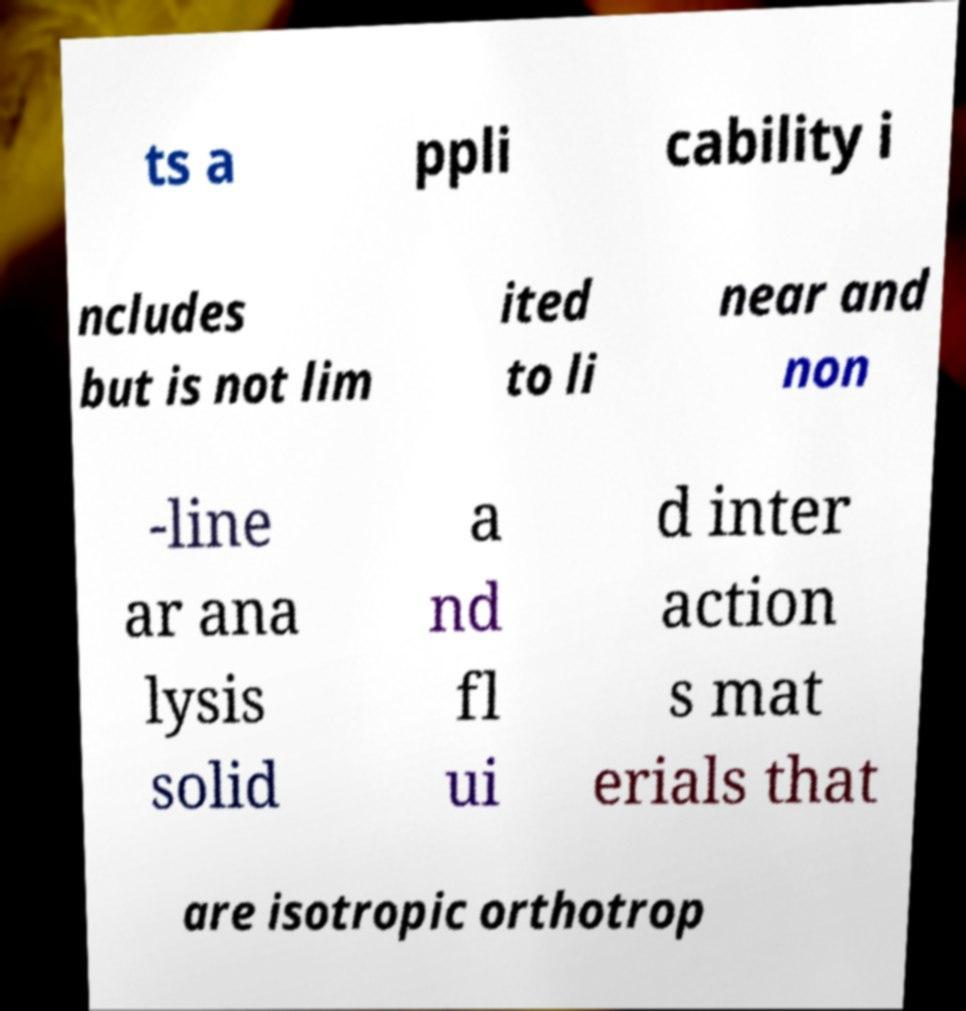For documentation purposes, I need the text within this image transcribed. Could you provide that? ts a ppli cability i ncludes but is not lim ited to li near and non -line ar ana lysis solid a nd fl ui d inter action s mat erials that are isotropic orthotrop 